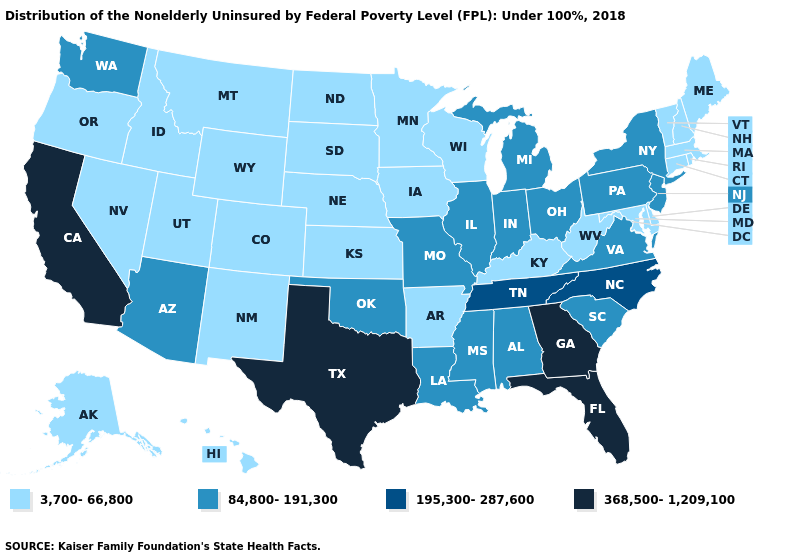What is the lowest value in the MidWest?
Write a very short answer. 3,700-66,800. Does Indiana have the lowest value in the MidWest?
Quick response, please. No. Does Iowa have a lower value than Florida?
Be succinct. Yes. Name the states that have a value in the range 3,700-66,800?
Keep it brief. Alaska, Arkansas, Colorado, Connecticut, Delaware, Hawaii, Idaho, Iowa, Kansas, Kentucky, Maine, Maryland, Massachusetts, Minnesota, Montana, Nebraska, Nevada, New Hampshire, New Mexico, North Dakota, Oregon, Rhode Island, South Dakota, Utah, Vermont, West Virginia, Wisconsin, Wyoming. Among the states that border Virginia , does Kentucky have the highest value?
Keep it brief. No. Name the states that have a value in the range 84,800-191,300?
Concise answer only. Alabama, Arizona, Illinois, Indiana, Louisiana, Michigan, Mississippi, Missouri, New Jersey, New York, Ohio, Oklahoma, Pennsylvania, South Carolina, Virginia, Washington. Which states hav the highest value in the MidWest?
Short answer required. Illinois, Indiana, Michigan, Missouri, Ohio. Does Indiana have the lowest value in the USA?
Short answer required. No. What is the highest value in states that border Louisiana?
Quick response, please. 368,500-1,209,100. Name the states that have a value in the range 368,500-1,209,100?
Answer briefly. California, Florida, Georgia, Texas. What is the value of Connecticut?
Be succinct. 3,700-66,800. What is the lowest value in the West?
Answer briefly. 3,700-66,800. Does Colorado have the lowest value in the West?
Write a very short answer. Yes. Name the states that have a value in the range 84,800-191,300?
Give a very brief answer. Alabama, Arizona, Illinois, Indiana, Louisiana, Michigan, Mississippi, Missouri, New Jersey, New York, Ohio, Oklahoma, Pennsylvania, South Carolina, Virginia, Washington. Does Texas have the lowest value in the USA?
Quick response, please. No. 